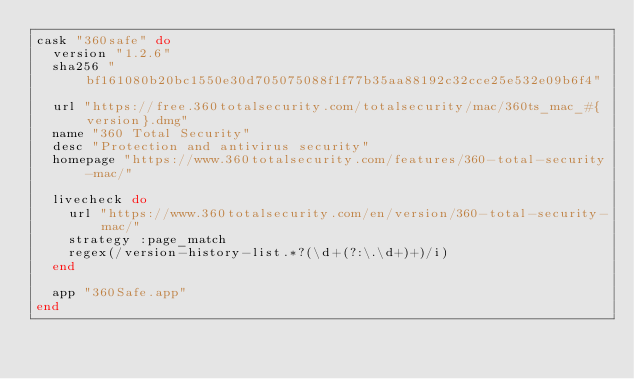Convert code to text. <code><loc_0><loc_0><loc_500><loc_500><_Ruby_>cask "360safe" do
  version "1.2.6"
  sha256 "bf161080b20bc1550e30d705075088f1f77b35aa88192c32cce25e532e09b6f4"

  url "https://free.360totalsecurity.com/totalsecurity/mac/360ts_mac_#{version}.dmg"
  name "360 Total Security"
  desc "Protection and antivirus security"
  homepage "https://www.360totalsecurity.com/features/360-total-security-mac/"

  livecheck do
    url "https://www.360totalsecurity.com/en/version/360-total-security-mac/"
    strategy :page_match
    regex(/version-history-list.*?(\d+(?:\.\d+)+)/i)
  end

  app "360Safe.app"
end
</code> 